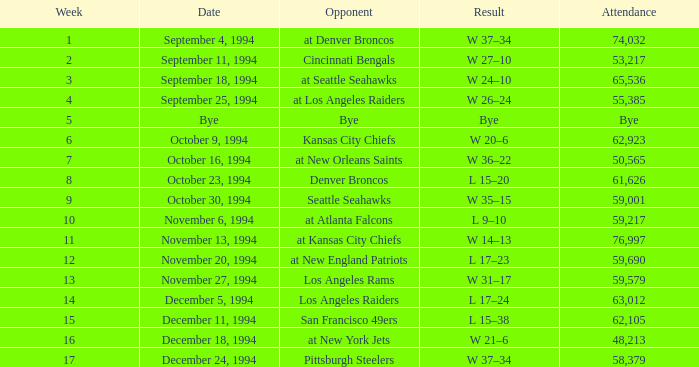On November 20, 1994, what was the result of the game? L 17–23. 